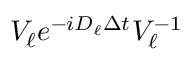Convert formula to latex. <formula><loc_0><loc_0><loc_500><loc_500>V _ { \ell } e ^ { - i D _ { \ell } \Delta t } V _ { \ell } ^ { - 1 }</formula> 